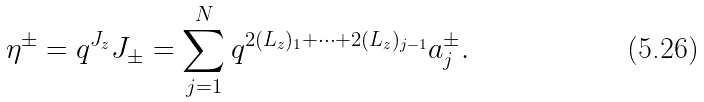<formula> <loc_0><loc_0><loc_500><loc_500>\eta ^ { \pm } = q ^ { J _ { z } } J _ { \pm } = \sum _ { j = 1 } ^ { N } q ^ { 2 ( L _ { z } ) _ { 1 } + \cdots + 2 ( L _ { z } ) _ { j - 1 } } a _ { j } ^ { \pm } .</formula> 